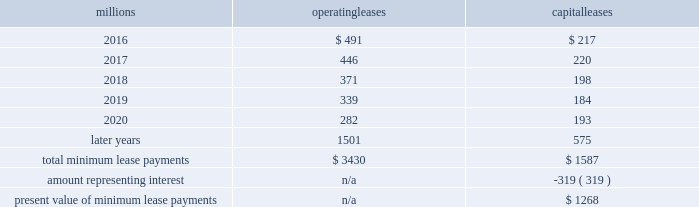We maintain and operate the assets based on contractual obligations within the lease arrangements , which set specific guidelines consistent within the railroad industry .
As such , we have no control over activities that could materially impact the fair value of the leased assets .
We do not hold the power to direct the activities of the vies and , therefore , do not control the ongoing activities that have a significant impact on the economic performance of the vies .
Additionally , we do not have the obligation to absorb losses of the vies or the right to receive benefits of the vies that could potentially be significant to the we are not considered to be the primary beneficiary and do not consolidate these vies because our actions and decisions do not have the most significant effect on the vie 2019s performance and our fixed-price purchase options are not considered to be potentially significant to the vies .
The future minimum lease payments associated with the vie leases totaled $ 2.6 billion as of december 31 , 2015 .
17 .
Leases we lease certain locomotives , freight cars , and other property .
The consolidated statements of financial position as of december 31 , 2015 and 2014 included $ 2273 million , net of $ 1189 million of accumulated depreciation , and $ 2454 million , net of $ 1210 million of accumulated depreciation , respectively , for properties held under capital leases .
A charge to income resulting from the depreciation for assets held under capital leases is included within depreciation expense in our consolidated statements of income .
Future minimum lease payments for operating and capital leases with initial or remaining non-cancelable lease terms in excess of one year as of december 31 , 2015 , were as follows : millions operating leases capital leases .
Approximately 95% ( 95 % ) of capital lease payments relate to locomotives .
Rent expense for operating leases with terms exceeding one month was $ 590 million in 2015 , $ 593 million in 2014 , and $ 618 million in 2013 .
When cash rental payments are not made on a straight-line basis , we recognize variable rental expense on a straight-line basis over the lease term .
Contingent rentals and sub-rentals are not significant .
18 .
Commitments and contingencies asserted and unasserted claims 2013 various claims and lawsuits are pending against us and certain of our subsidiaries .
We cannot fully determine the effect of all asserted and unasserted claims on our consolidated results of operations , financial condition , or liquidity .
To the extent possible , we have recorded a liability where asserted and unasserted claims are considered probable and where such claims can be reasonably estimated .
We do not expect that any known lawsuits , claims , environmental costs , commitments , contingent liabilities , or guarantees will have a material adverse effect on our consolidated results of operations , financial condition , or liquidity after taking into account liabilities and insurance recoveries previously recorded for these matters .
Personal injury 2013 the cost of personal injuries to employees and others related to our activities is charged to expense based on estimates of the ultimate cost and number of incidents each year .
We use an actuarial analysis to measure the expense and liability , including unasserted claims .
The federal employers 2019 liability act ( fela ) governs compensation for work-related accidents .
Under fela , damages are assessed based on a finding of fault through litigation or out-of-court settlements .
We offer a comprehensive variety of services and rehabilitation programs for employees who are injured at work .
Our personal injury liability is not discounted to present value due to the uncertainty surrounding the timing of future payments .
Approximately 94% ( 94 % ) of the recorded liability is related to asserted claims and .
In the consolidated statement of financial position what was the ratio of the properties held under capital leases in 2015 to 2014\\n? 
Computations: (2273 / 2454)
Answer: 0.92624. 